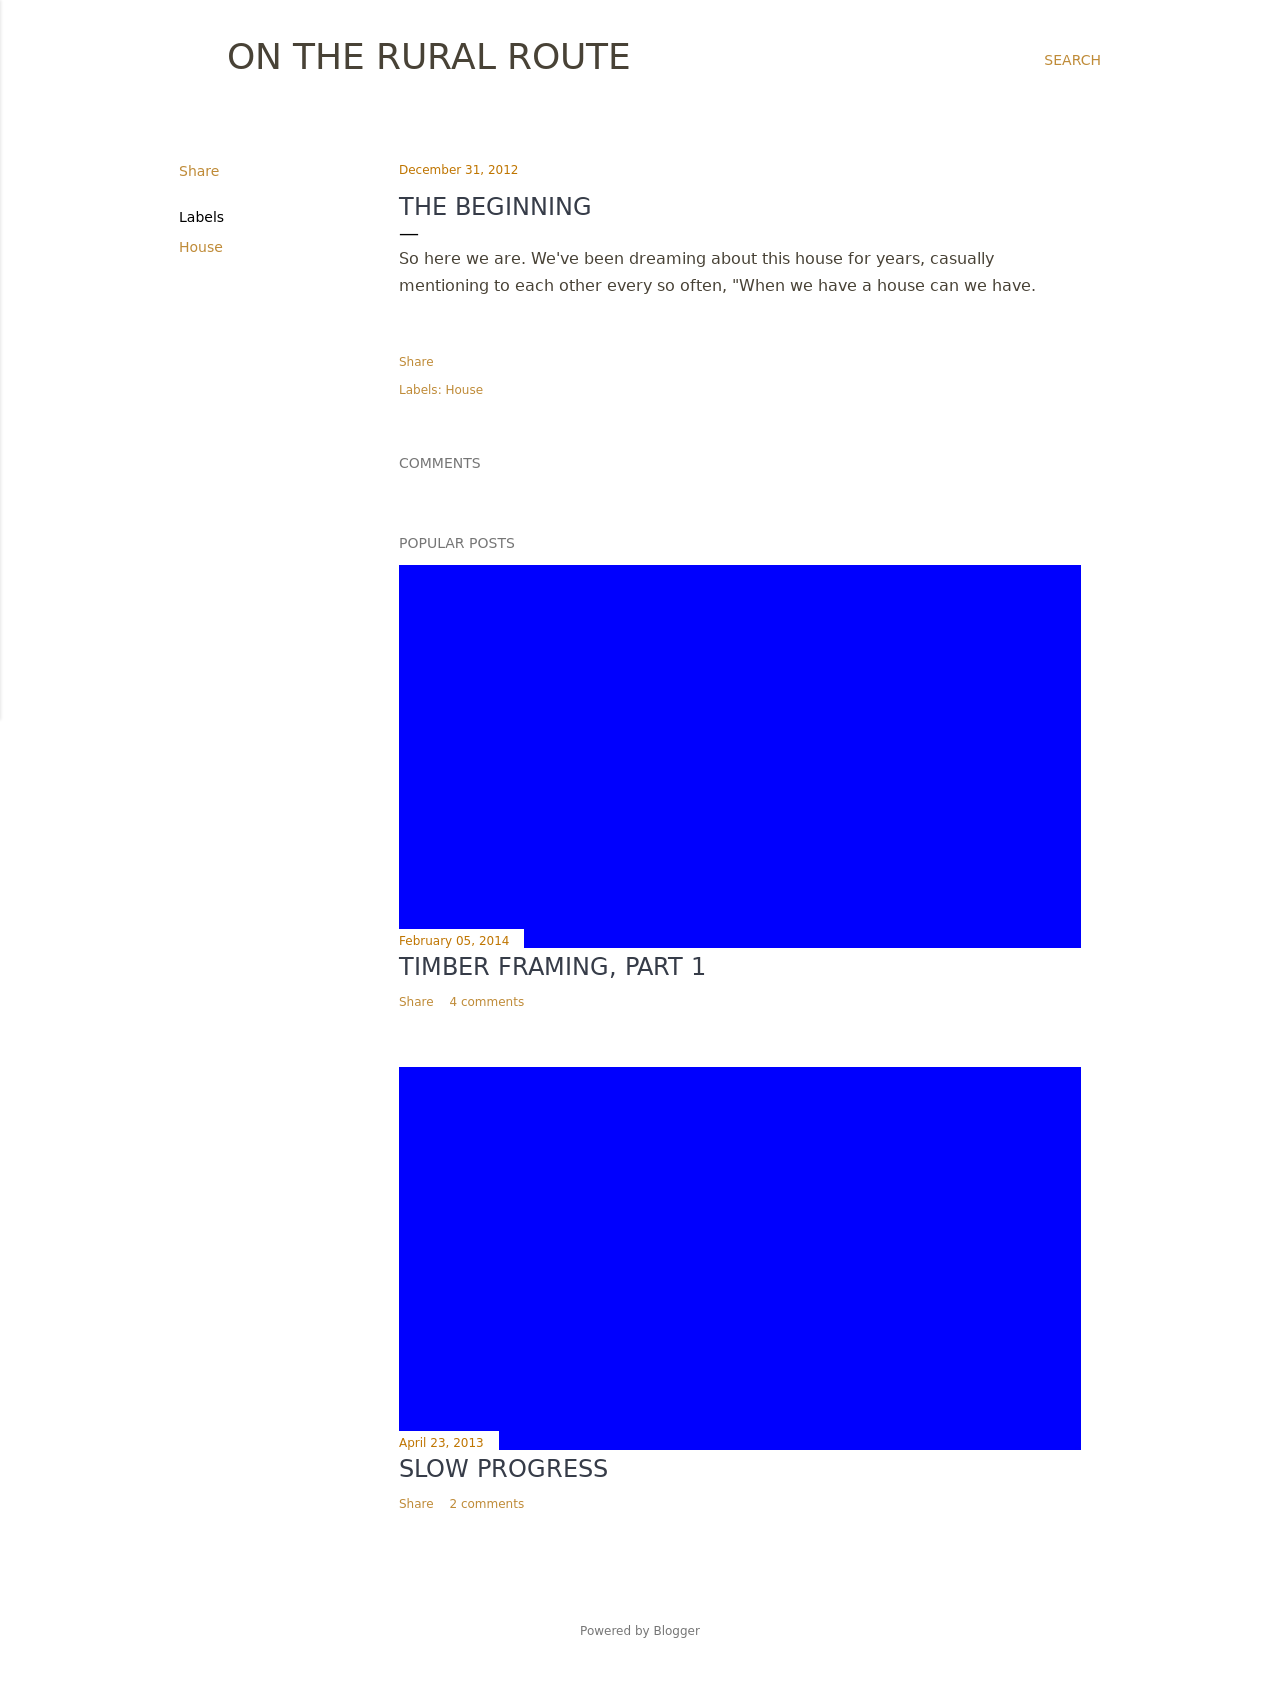How can I start building this website with HTML from the ground up? To build a website similar to the one depicted in the image, you would start with a basic HTML structure. First, you should define the doctype and language attributes at the beginning of your HTML. Next, it's essential to set a responsive <meta> viewport tag in your <head> section to ensure the website adapts well to different device sizes. The <title> element can reflect the main purpose or topic of your website, for example 'On the Rural Route'. Within the body, consider using container divs to manage the layout, styled with CSS. Include images, headers, and text sections to mirror the original site's layout and style, focusing on creating a clean, navigable structure that enhances user experience. 